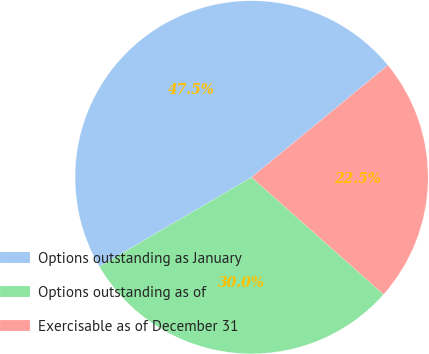Convert chart to OTSL. <chart><loc_0><loc_0><loc_500><loc_500><pie_chart><fcel>Options outstanding as January<fcel>Options outstanding as of<fcel>Exercisable as of December 31<nl><fcel>47.5%<fcel>30.0%<fcel>22.5%<nl></chart> 